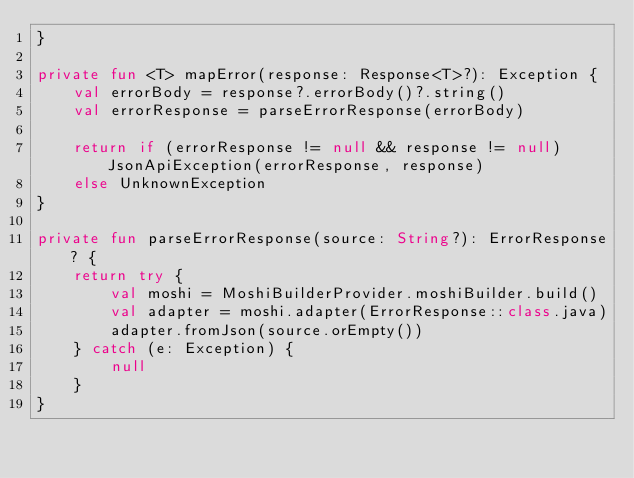<code> <loc_0><loc_0><loc_500><loc_500><_Kotlin_>}

private fun <T> mapError(response: Response<T>?): Exception {
    val errorBody = response?.errorBody()?.string()
    val errorResponse = parseErrorResponse(errorBody)

    return if (errorResponse != null && response != null) JsonApiException(errorResponse, response)
    else UnknownException
}

private fun parseErrorResponse(source: String?): ErrorResponse? {
    return try {
        val moshi = MoshiBuilderProvider.moshiBuilder.build()
        val adapter = moshi.adapter(ErrorResponse::class.java)
        adapter.fromJson(source.orEmpty())
    } catch (e: Exception) {
        null
    }
}
</code> 